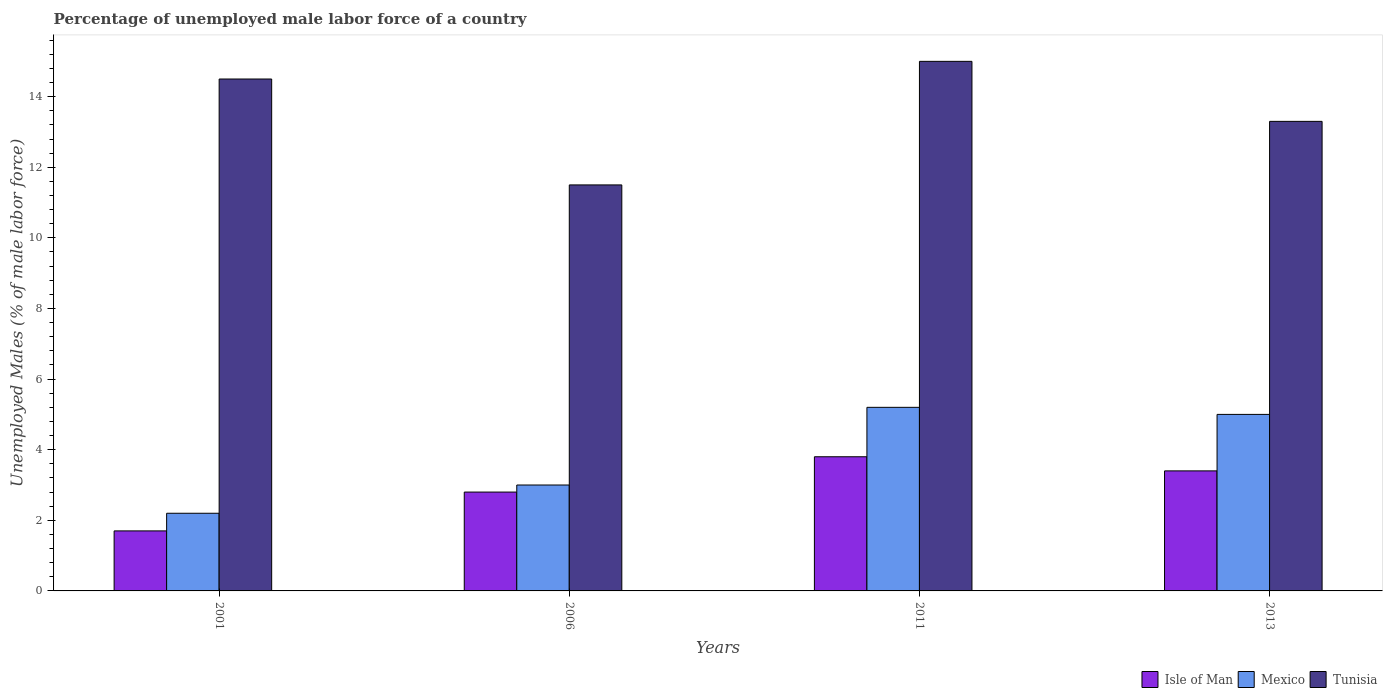How many different coloured bars are there?
Your response must be concise. 3. How many groups of bars are there?
Ensure brevity in your answer.  4. Are the number of bars on each tick of the X-axis equal?
Offer a terse response. Yes. How many bars are there on the 2nd tick from the left?
Offer a very short reply. 3. What is the label of the 4th group of bars from the left?
Your response must be concise. 2013. What is the percentage of unemployed male labor force in Mexico in 2001?
Your answer should be compact. 2.2. Across all years, what is the maximum percentage of unemployed male labor force in Mexico?
Make the answer very short. 5.2. Across all years, what is the minimum percentage of unemployed male labor force in Mexico?
Provide a short and direct response. 2.2. In which year was the percentage of unemployed male labor force in Tunisia maximum?
Offer a very short reply. 2011. What is the total percentage of unemployed male labor force in Tunisia in the graph?
Your answer should be very brief. 54.3. What is the difference between the percentage of unemployed male labor force in Isle of Man in 2001 and the percentage of unemployed male labor force in Tunisia in 2006?
Your answer should be compact. -9.8. What is the average percentage of unemployed male labor force in Mexico per year?
Keep it short and to the point. 3.85. In the year 2011, what is the difference between the percentage of unemployed male labor force in Tunisia and percentage of unemployed male labor force in Mexico?
Your answer should be compact. 9.8. In how many years, is the percentage of unemployed male labor force in Isle of Man greater than 0.8 %?
Provide a short and direct response. 4. What is the ratio of the percentage of unemployed male labor force in Isle of Man in 2011 to that in 2013?
Provide a succinct answer. 1.12. Is the percentage of unemployed male labor force in Tunisia in 2001 less than that in 2013?
Make the answer very short. No. Is the difference between the percentage of unemployed male labor force in Tunisia in 2006 and 2013 greater than the difference between the percentage of unemployed male labor force in Mexico in 2006 and 2013?
Offer a terse response. Yes. What is the difference between the highest and the second highest percentage of unemployed male labor force in Mexico?
Keep it short and to the point. 0.2. What is the difference between the highest and the lowest percentage of unemployed male labor force in Isle of Man?
Offer a very short reply. 2.1. In how many years, is the percentage of unemployed male labor force in Tunisia greater than the average percentage of unemployed male labor force in Tunisia taken over all years?
Make the answer very short. 2. What does the 3rd bar from the left in 2006 represents?
Keep it short and to the point. Tunisia. Are all the bars in the graph horizontal?
Give a very brief answer. No. How many years are there in the graph?
Keep it short and to the point. 4. What is the difference between two consecutive major ticks on the Y-axis?
Offer a very short reply. 2. Are the values on the major ticks of Y-axis written in scientific E-notation?
Provide a short and direct response. No. Does the graph contain any zero values?
Your answer should be very brief. No. Where does the legend appear in the graph?
Your response must be concise. Bottom right. How many legend labels are there?
Make the answer very short. 3. How are the legend labels stacked?
Ensure brevity in your answer.  Horizontal. What is the title of the graph?
Your answer should be compact. Percentage of unemployed male labor force of a country. Does "Colombia" appear as one of the legend labels in the graph?
Your response must be concise. No. What is the label or title of the Y-axis?
Provide a succinct answer. Unemployed Males (% of male labor force). What is the Unemployed Males (% of male labor force) in Isle of Man in 2001?
Make the answer very short. 1.7. What is the Unemployed Males (% of male labor force) in Mexico in 2001?
Your response must be concise. 2.2. What is the Unemployed Males (% of male labor force) in Isle of Man in 2006?
Your answer should be very brief. 2.8. What is the Unemployed Males (% of male labor force) of Mexico in 2006?
Your answer should be very brief. 3. What is the Unemployed Males (% of male labor force) in Tunisia in 2006?
Keep it short and to the point. 11.5. What is the Unemployed Males (% of male labor force) in Isle of Man in 2011?
Your answer should be compact. 3.8. What is the Unemployed Males (% of male labor force) of Mexico in 2011?
Your answer should be compact. 5.2. What is the Unemployed Males (% of male labor force) in Isle of Man in 2013?
Give a very brief answer. 3.4. What is the Unemployed Males (% of male labor force) of Mexico in 2013?
Make the answer very short. 5. What is the Unemployed Males (% of male labor force) of Tunisia in 2013?
Provide a succinct answer. 13.3. Across all years, what is the maximum Unemployed Males (% of male labor force) in Isle of Man?
Keep it short and to the point. 3.8. Across all years, what is the maximum Unemployed Males (% of male labor force) in Mexico?
Provide a short and direct response. 5.2. Across all years, what is the maximum Unemployed Males (% of male labor force) of Tunisia?
Keep it short and to the point. 15. Across all years, what is the minimum Unemployed Males (% of male labor force) in Isle of Man?
Provide a short and direct response. 1.7. Across all years, what is the minimum Unemployed Males (% of male labor force) in Mexico?
Provide a short and direct response. 2.2. What is the total Unemployed Males (% of male labor force) of Isle of Man in the graph?
Provide a short and direct response. 11.7. What is the total Unemployed Males (% of male labor force) in Tunisia in the graph?
Ensure brevity in your answer.  54.3. What is the difference between the Unemployed Males (% of male labor force) of Isle of Man in 2001 and that in 2006?
Your answer should be compact. -1.1. What is the difference between the Unemployed Males (% of male labor force) in Mexico in 2001 and that in 2006?
Your answer should be very brief. -0.8. What is the difference between the Unemployed Males (% of male labor force) in Isle of Man in 2001 and that in 2011?
Make the answer very short. -2.1. What is the difference between the Unemployed Males (% of male labor force) of Tunisia in 2001 and that in 2011?
Offer a very short reply. -0.5. What is the difference between the Unemployed Males (% of male labor force) in Isle of Man in 2006 and that in 2011?
Provide a succinct answer. -1. What is the difference between the Unemployed Males (% of male labor force) of Mexico in 2006 and that in 2011?
Make the answer very short. -2.2. What is the difference between the Unemployed Males (% of male labor force) of Isle of Man in 2011 and that in 2013?
Offer a very short reply. 0.4. What is the difference between the Unemployed Males (% of male labor force) of Mexico in 2001 and the Unemployed Males (% of male labor force) of Tunisia in 2011?
Your response must be concise. -12.8. What is the difference between the Unemployed Males (% of male labor force) in Mexico in 2001 and the Unemployed Males (% of male labor force) in Tunisia in 2013?
Your answer should be compact. -11.1. What is the difference between the Unemployed Males (% of male labor force) in Isle of Man in 2006 and the Unemployed Males (% of male labor force) in Mexico in 2011?
Give a very brief answer. -2.4. What is the difference between the Unemployed Males (% of male labor force) in Isle of Man in 2006 and the Unemployed Males (% of male labor force) in Tunisia in 2011?
Your answer should be compact. -12.2. What is the difference between the Unemployed Males (% of male labor force) in Isle of Man in 2006 and the Unemployed Males (% of male labor force) in Mexico in 2013?
Offer a terse response. -2.2. What is the difference between the Unemployed Males (% of male labor force) in Isle of Man in 2011 and the Unemployed Males (% of male labor force) in Mexico in 2013?
Your answer should be very brief. -1.2. What is the average Unemployed Males (% of male labor force) in Isle of Man per year?
Your response must be concise. 2.92. What is the average Unemployed Males (% of male labor force) in Mexico per year?
Give a very brief answer. 3.85. What is the average Unemployed Males (% of male labor force) of Tunisia per year?
Make the answer very short. 13.57. In the year 2001, what is the difference between the Unemployed Males (% of male labor force) in Isle of Man and Unemployed Males (% of male labor force) in Mexico?
Ensure brevity in your answer.  -0.5. In the year 2011, what is the difference between the Unemployed Males (% of male labor force) in Isle of Man and Unemployed Males (% of male labor force) in Tunisia?
Offer a terse response. -11.2. In the year 2013, what is the difference between the Unemployed Males (% of male labor force) of Isle of Man and Unemployed Males (% of male labor force) of Tunisia?
Provide a succinct answer. -9.9. What is the ratio of the Unemployed Males (% of male labor force) in Isle of Man in 2001 to that in 2006?
Your answer should be very brief. 0.61. What is the ratio of the Unemployed Males (% of male labor force) in Mexico in 2001 to that in 2006?
Provide a succinct answer. 0.73. What is the ratio of the Unemployed Males (% of male labor force) in Tunisia in 2001 to that in 2006?
Provide a succinct answer. 1.26. What is the ratio of the Unemployed Males (% of male labor force) of Isle of Man in 2001 to that in 2011?
Your response must be concise. 0.45. What is the ratio of the Unemployed Males (% of male labor force) of Mexico in 2001 to that in 2011?
Give a very brief answer. 0.42. What is the ratio of the Unemployed Males (% of male labor force) of Tunisia in 2001 to that in 2011?
Offer a very short reply. 0.97. What is the ratio of the Unemployed Males (% of male labor force) in Mexico in 2001 to that in 2013?
Make the answer very short. 0.44. What is the ratio of the Unemployed Males (% of male labor force) of Tunisia in 2001 to that in 2013?
Offer a very short reply. 1.09. What is the ratio of the Unemployed Males (% of male labor force) of Isle of Man in 2006 to that in 2011?
Make the answer very short. 0.74. What is the ratio of the Unemployed Males (% of male labor force) in Mexico in 2006 to that in 2011?
Provide a succinct answer. 0.58. What is the ratio of the Unemployed Males (% of male labor force) in Tunisia in 2006 to that in 2011?
Your response must be concise. 0.77. What is the ratio of the Unemployed Males (% of male labor force) in Isle of Man in 2006 to that in 2013?
Your answer should be compact. 0.82. What is the ratio of the Unemployed Males (% of male labor force) of Mexico in 2006 to that in 2013?
Make the answer very short. 0.6. What is the ratio of the Unemployed Males (% of male labor force) of Tunisia in 2006 to that in 2013?
Offer a very short reply. 0.86. What is the ratio of the Unemployed Males (% of male labor force) of Isle of Man in 2011 to that in 2013?
Ensure brevity in your answer.  1.12. What is the ratio of the Unemployed Males (% of male labor force) in Mexico in 2011 to that in 2013?
Keep it short and to the point. 1.04. What is the ratio of the Unemployed Males (% of male labor force) of Tunisia in 2011 to that in 2013?
Make the answer very short. 1.13. What is the difference between the highest and the second highest Unemployed Males (% of male labor force) in Tunisia?
Ensure brevity in your answer.  0.5. What is the difference between the highest and the lowest Unemployed Males (% of male labor force) of Isle of Man?
Provide a short and direct response. 2.1. 